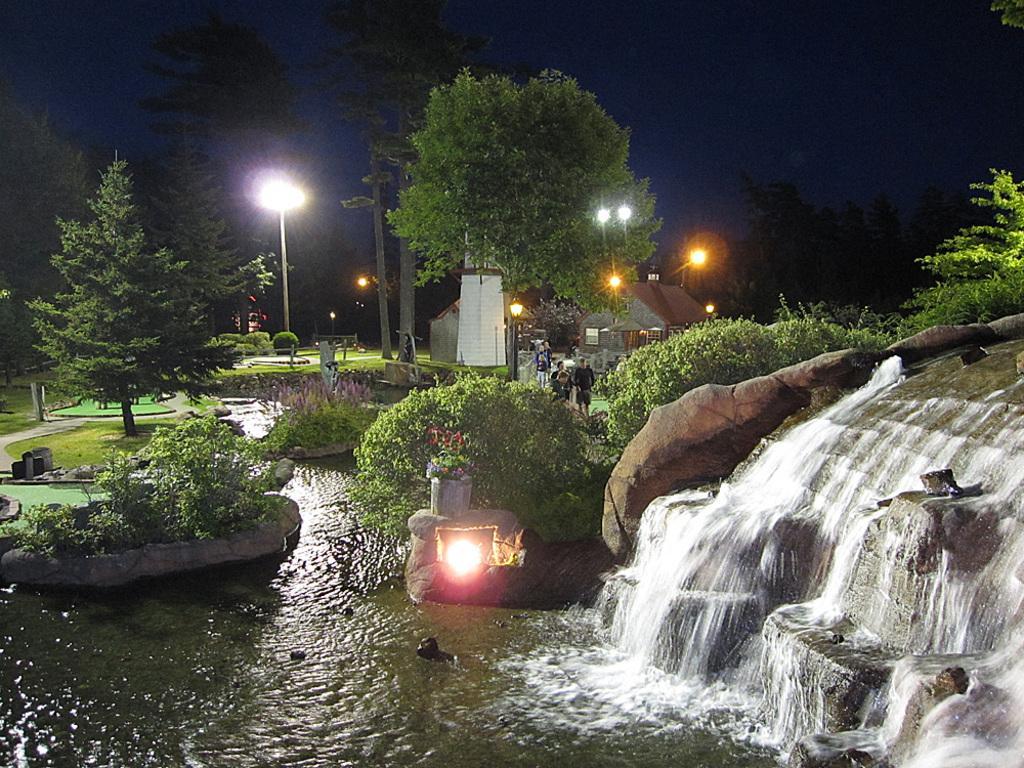Please provide a concise description of this image. In this image there is the sky, there are trees, there is a house, there is pole, there are lights, there is a waterfall, there is a rock truncated towards the right of the image, there is a tree truncated towards the right of the image, there is the grass, there is board, there are trees truncated towards the left of the image, there are two persons standing. 